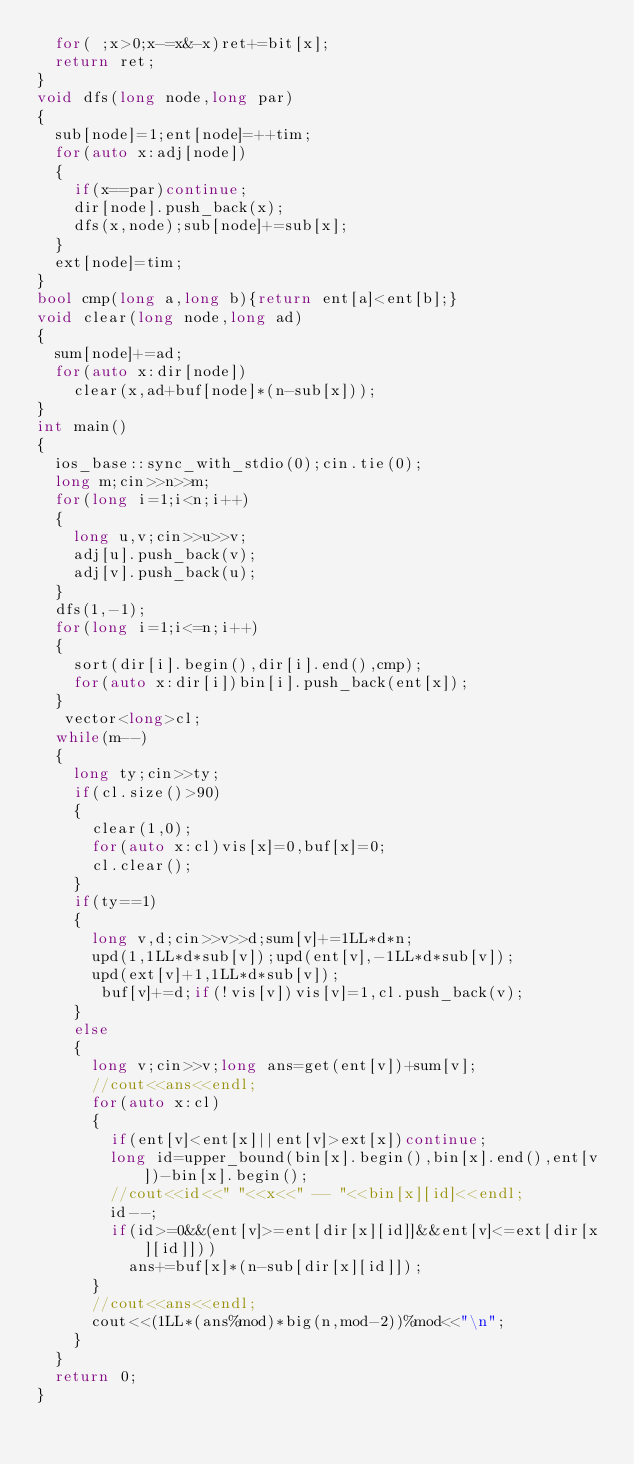Convert code to text. <code><loc_0><loc_0><loc_500><loc_500><_C++_>  for( ;x>0;x-=x&-x)ret+=bit[x];
  return ret;
}
void dfs(long node,long par)
{
  sub[node]=1;ent[node]=++tim;
  for(auto x:adj[node])
  {
    if(x==par)continue;
    dir[node].push_back(x);
    dfs(x,node);sub[node]+=sub[x];
  }
  ext[node]=tim;
}
bool cmp(long a,long b){return ent[a]<ent[b];}
void clear(long node,long ad)
{
  sum[node]+=ad;
  for(auto x:dir[node])
    clear(x,ad+buf[node]*(n-sub[x]));
}
int main()
{
  ios_base::sync_with_stdio(0);cin.tie(0);
  long m;cin>>n>>m;
  for(long i=1;i<n;i++)
  {
    long u,v;cin>>u>>v;
    adj[u].push_back(v);
    adj[v].push_back(u);
  }
  dfs(1,-1);
  for(long i=1;i<=n;i++)
  {
    sort(dir[i].begin(),dir[i].end(),cmp);
    for(auto x:dir[i])bin[i].push_back(ent[x]);
  }
   vector<long>cl;
  while(m--)
  {
    long ty;cin>>ty;
    if(cl.size()>90)
    {
      clear(1,0);
      for(auto x:cl)vis[x]=0,buf[x]=0;
      cl.clear();
    }
    if(ty==1)
    {
      long v,d;cin>>v>>d;sum[v]+=1LL*d*n;
      upd(1,1LL*d*sub[v]);upd(ent[v],-1LL*d*sub[v]);
      upd(ext[v]+1,1LL*d*sub[v]);
       buf[v]+=d;if(!vis[v])vis[v]=1,cl.push_back(v);
    }
    else
    {
      long v;cin>>v;long ans=get(ent[v])+sum[v];
      //cout<<ans<<endl;
      for(auto x:cl)
      {
        if(ent[v]<ent[x]||ent[v]>ext[x])continue;
        long id=upper_bound(bin[x].begin(),bin[x].end(),ent[v])-bin[x].begin();
        //cout<<id<<" "<<x<<" -- "<<bin[x][id]<<endl;
        id--;
        if(id>=0&&(ent[v]>=ent[dir[x][id]]&&ent[v]<=ext[dir[x][id]]))
          ans+=buf[x]*(n-sub[dir[x][id]]);
      }
      //cout<<ans<<endl;
      cout<<(1LL*(ans%mod)*big(n,mod-2))%mod<<"\n";
    }
  }
  return 0;
}</code> 